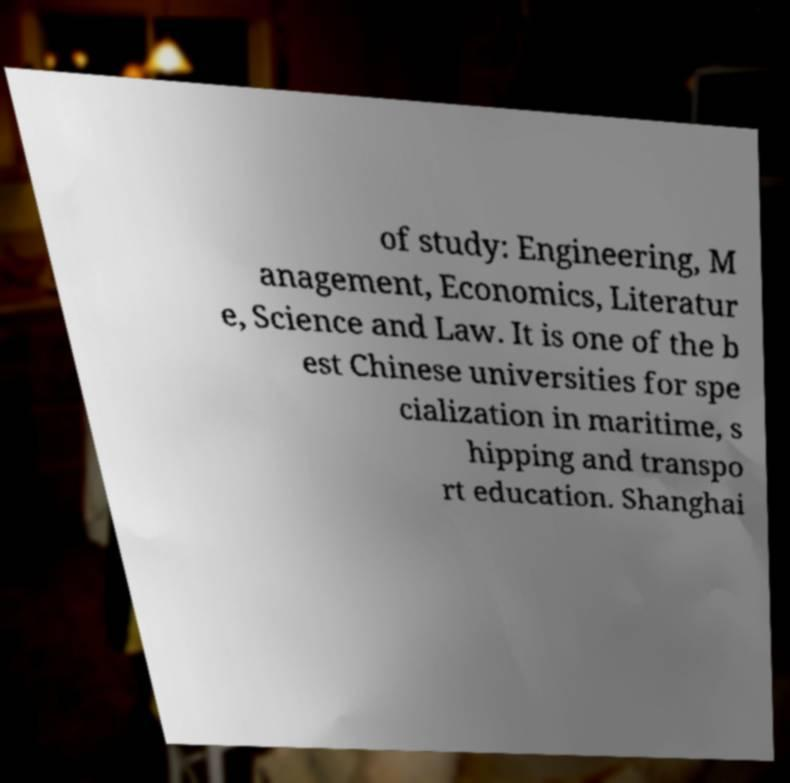Could you extract and type out the text from this image? of study: Engineering, M anagement, Economics, Literatur e, Science and Law. It is one of the b est Chinese universities for spe cialization in maritime, s hipping and transpo rt education. Shanghai 